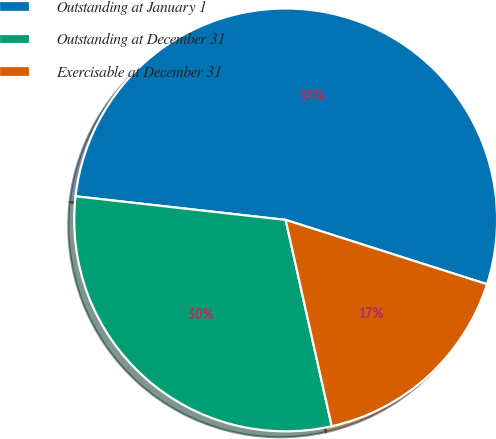<chart> <loc_0><loc_0><loc_500><loc_500><pie_chart><fcel>Outstanding at January 1<fcel>Outstanding at December 31<fcel>Exercisable at December 31<nl><fcel>53.14%<fcel>30.28%<fcel>16.58%<nl></chart> 